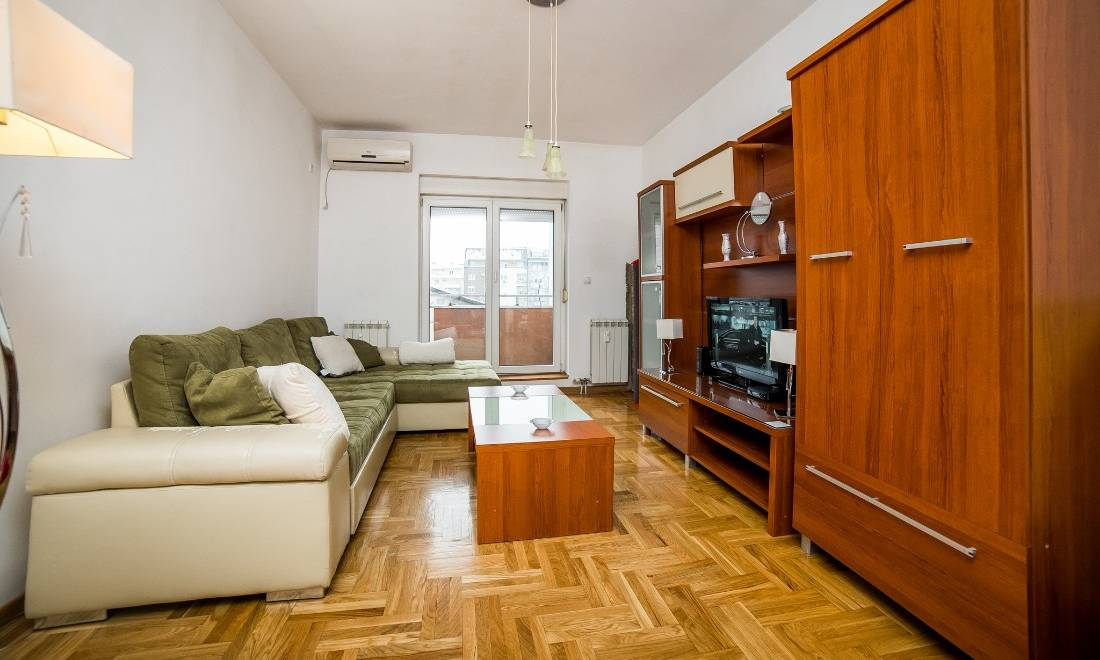Imagine the conversations happening in this living room. What topics might come up? In this inviting living room, conversations might revolve around favorite movies or TV shows, given the prominent placement of the entertainment system. Guests might discuss recent events or share personal stories as they relax on the comfortable sofa. The casual, yet organized environment could also prompt discussions about home decor and lifestyle preferences, perhaps sharing tips on maintaining a minimalist and tidy home. The serene, clean setting might even inspire more heartfelt or philosophical conversations about life, priorities, and the importance of creating a peaceful living space. If these shelves could talk, what stories would they tell? The shelves, with their minimalist display, might tell stories of simplicity and selective appreciation. Each item – the vases, the figurine, the clock – could represent moments of thoughtful choices and careful curation. They might speak of a homeowner who values quality over quantity, perhaps reminiscing about the quiet afternoons spent enjoying the neatness and calm of the room. The decorative pieces might share tales of being part of a peaceful retreat from the bustling world outside, contributing to an environment where every item has its own space and significance. The shelves could also hint at the ever-changing nature of the room, where fewer items mean the possibility for frequent refreshes and updates to the decor.  If this room were part of a movie set, what genre would it be and how would it be used in a scene? If this room were part of a movie set, it would perfectly suit a romantic-comedy or a contemporary drama. The cozy and orderly setting could provide a backdrop for intimate, heartwarming scenes where characters share personal moments, confessions, or engage in lighthearted banter. The living room, with its inviting sofa and practical design, would be the ideal location for a key scene where characters bond over tea, share a heartfelt conversation that marks a turning point in their relationship, or relax together at the end of a hectic day, reflecting on life's events. The minimalist decor would not distract from the performances, allowing the audience to focus on the characters' interactions and emotions.  Create a backstory for the owner of this living room, including their profession, hobbies, and a typical day in their life. The owner of this living room is Alex, a freelance graphic designer in their early thirties. Alex enjoys the flexibility of working from home, often spending mornings designing creative projects for a diverse clientele. The minimalist setting of the living room reflects their artistic yet practical nature, ensuring a clutter-free environment that sparks creativity. After completing daily work tasks, Alex likes to unwind here, either binge-watching favorite TV series or reading a good book on the comfortable L-shaped sofa, with a cup of herbal tea on the elegant coffee table. Weekends are reserved for hosting friends for movie nights or small get-togethers, showcasing Alex's love for an organized, welcoming space that encourages relaxation and quality time. Gardening and tending to a few plants on the balcony is another favorite hobby, representing a cherished break from digital screens and adding a touch of green serenity to their home. 